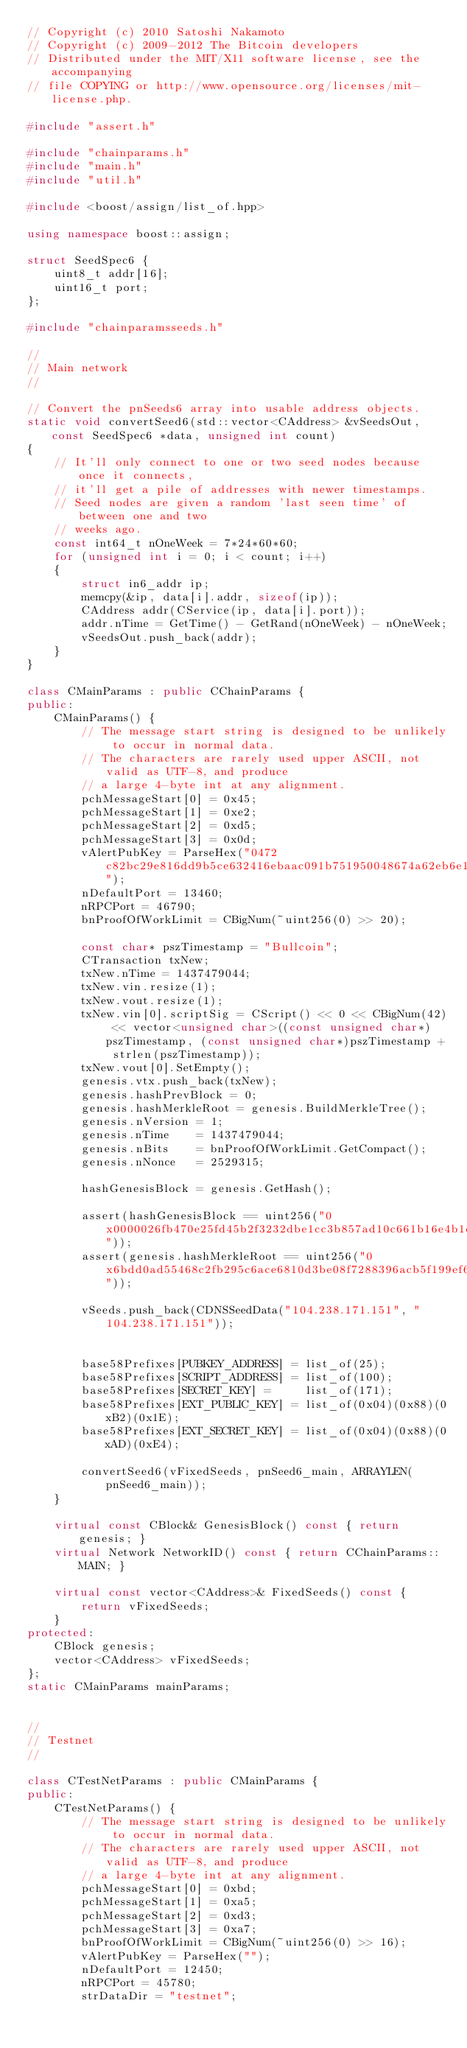Convert code to text. <code><loc_0><loc_0><loc_500><loc_500><_C++_>// Copyright (c) 2010 Satoshi Nakamoto
// Copyright (c) 2009-2012 The Bitcoin developers
// Distributed under the MIT/X11 software license, see the accompanying
// file COPYING or http://www.opensource.org/licenses/mit-license.php.

#include "assert.h"

#include "chainparams.h"
#include "main.h"
#include "util.h"

#include <boost/assign/list_of.hpp>

using namespace boost::assign;

struct SeedSpec6 {
    uint8_t addr[16];
    uint16_t port;
};

#include "chainparamsseeds.h"

//
// Main network
//

// Convert the pnSeeds6 array into usable address objects.
static void convertSeed6(std::vector<CAddress> &vSeedsOut, const SeedSpec6 *data, unsigned int count)
{
    // It'll only connect to one or two seed nodes because once it connects,
    // it'll get a pile of addresses with newer timestamps.
    // Seed nodes are given a random 'last seen time' of between one and two
    // weeks ago.
    const int64_t nOneWeek = 7*24*60*60;
    for (unsigned int i = 0; i < count; i++)
    {
        struct in6_addr ip;
        memcpy(&ip, data[i].addr, sizeof(ip));
        CAddress addr(CService(ip, data[i].port));
        addr.nTime = GetTime() - GetRand(nOneWeek) - nOneWeek;
        vSeedsOut.push_back(addr);
    }
}

class CMainParams : public CChainParams {
public:
    CMainParams() {
        // The message start string is designed to be unlikely to occur in normal data.
        // The characters are rarely used upper ASCII, not valid as UTF-8, and produce
        // a large 4-byte int at any alignment.
        pchMessageStart[0] = 0x45;
        pchMessageStart[1] = 0xe2;
        pchMessageStart[2] = 0xd5;
        pchMessageStart[3] = 0x0d;
        vAlertPubKey = ParseHex("0472c82bc29e816dd9b5ce632416ebaac091b751950048674a62eb6e17c93af858cb38fcd71ecc65dabe69a478502b0c2cb5b44e005450c2a52596d470fc137fb3");
        nDefaultPort = 13460;
        nRPCPort = 46790;
        bnProofOfWorkLimit = CBigNum(~uint256(0) >> 20);

        const char* pszTimestamp = "Bullcoin";
        CTransaction txNew;
        txNew.nTime = 1437479044;
        txNew.vin.resize(1);
        txNew.vout.resize(1);
        txNew.vin[0].scriptSig = CScript() << 0 << CBigNum(42) << vector<unsigned char>((const unsigned char*)pszTimestamp, (const unsigned char*)pszTimestamp + strlen(pszTimestamp));
        txNew.vout[0].SetEmpty();
        genesis.vtx.push_back(txNew);
        genesis.hashPrevBlock = 0;
        genesis.hashMerkleRoot = genesis.BuildMerkleTree();
        genesis.nVersion = 1;
        genesis.nTime    = 1437479044;
        genesis.nBits    = bnProofOfWorkLimit.GetCompact();
        genesis.nNonce   = 2529315;

        hashGenesisBlock = genesis.GetHash();

        assert(hashGenesisBlock == uint256("0x0000026fb470e25fd45b2f3232dbe1cc3b857ad10c661b16e4b1cebf56ab255d"));
        assert(genesis.hashMerkleRoot == uint256("0x6bdd0ad55468c2fb295c6ace6810d3be08f7288396acb5f199ef6b3586077300"));

        vSeeds.push_back(CDNSSeedData("104.238.171.151", "104.238.171.151"));


        base58Prefixes[PUBKEY_ADDRESS] = list_of(25);
        base58Prefixes[SCRIPT_ADDRESS] = list_of(100);
        base58Prefixes[SECRET_KEY] =     list_of(171);
        base58Prefixes[EXT_PUBLIC_KEY] = list_of(0x04)(0x88)(0xB2)(0x1E);
        base58Prefixes[EXT_SECRET_KEY] = list_of(0x04)(0x88)(0xAD)(0xE4);

        convertSeed6(vFixedSeeds, pnSeed6_main, ARRAYLEN(pnSeed6_main));
    }

    virtual const CBlock& GenesisBlock() const { return genesis; }
    virtual Network NetworkID() const { return CChainParams::MAIN; }

    virtual const vector<CAddress>& FixedSeeds() const {
        return vFixedSeeds;
    }
protected:
    CBlock genesis;
    vector<CAddress> vFixedSeeds;
};
static CMainParams mainParams;


//
// Testnet
//

class CTestNetParams : public CMainParams {
public:
    CTestNetParams() {
        // The message start string is designed to be unlikely to occur in normal data.
        // The characters are rarely used upper ASCII, not valid as UTF-8, and produce
        // a large 4-byte int at any alignment.
        pchMessageStart[0] = 0xbd;
        pchMessageStart[1] = 0xa5;
        pchMessageStart[2] = 0xd3;
        pchMessageStart[3] = 0xa7;
        bnProofOfWorkLimit = CBigNum(~uint256(0) >> 16);
        vAlertPubKey = ParseHex("");
        nDefaultPort = 12450;
        nRPCPort = 45780;
        strDataDir = "testnet";
</code> 